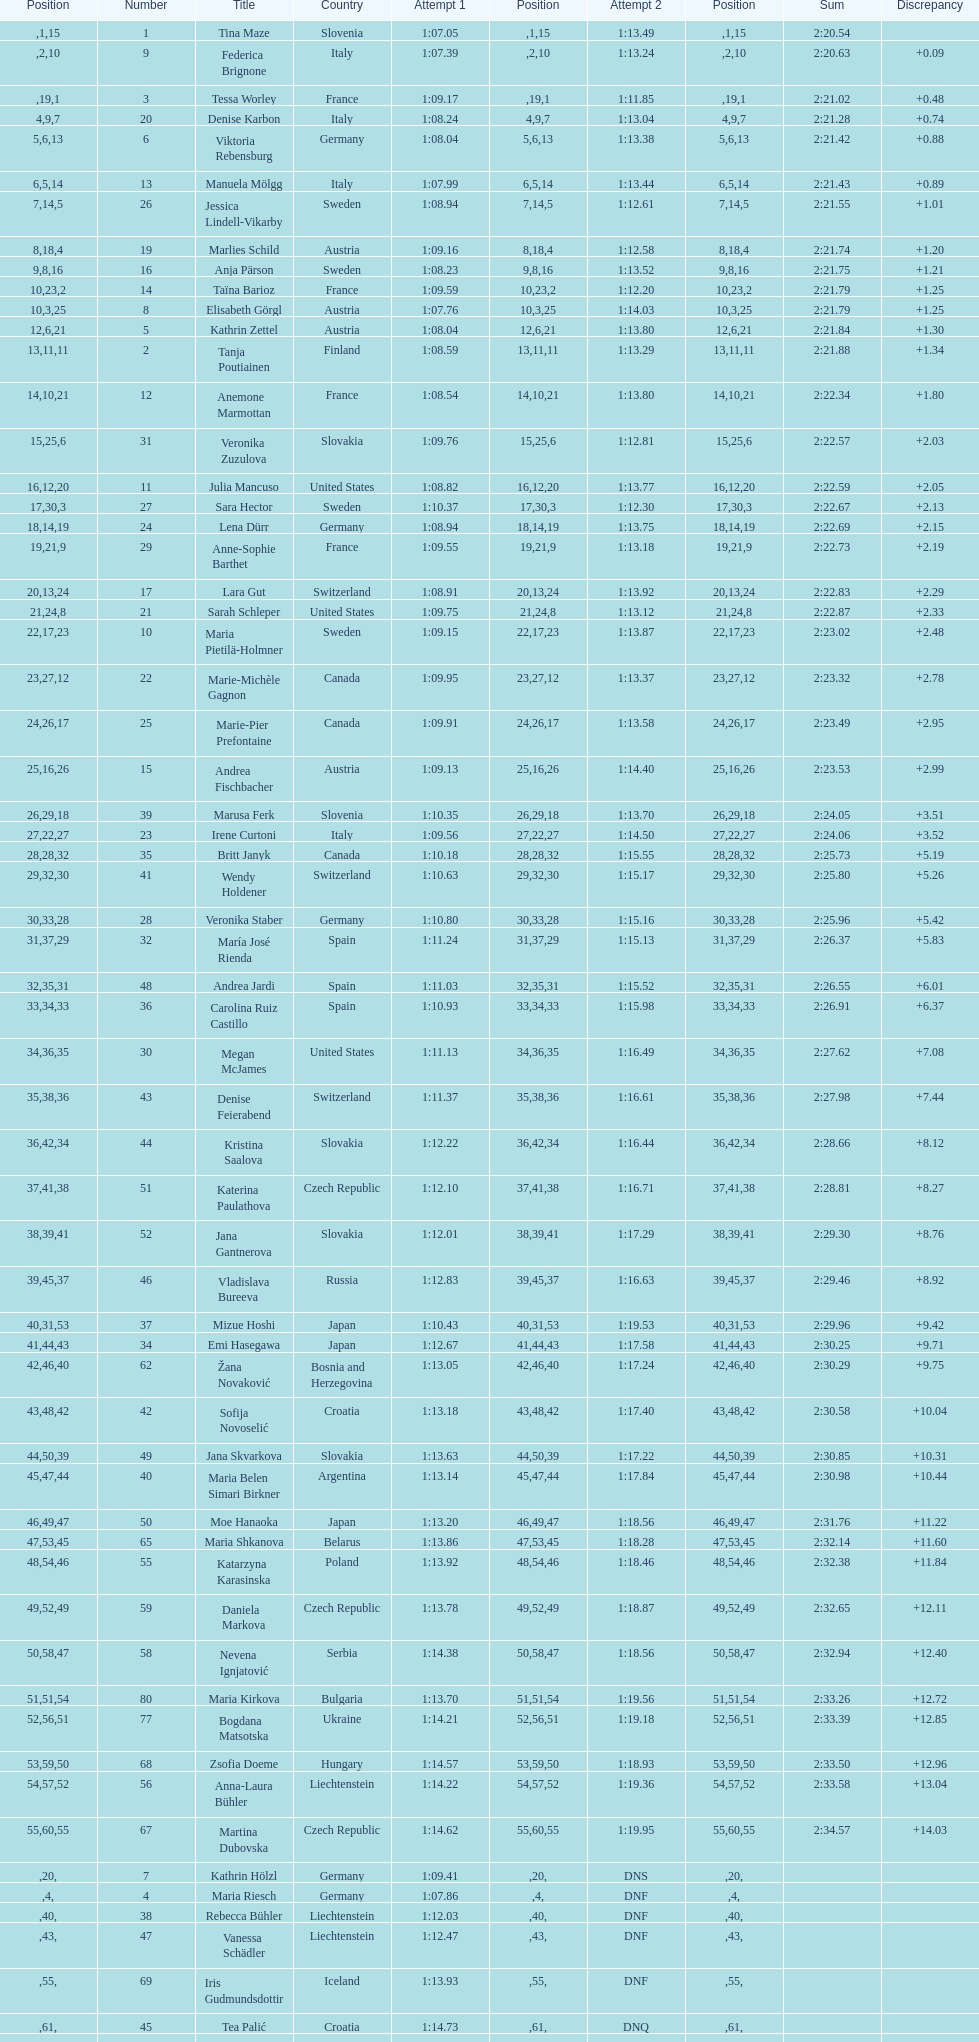Who was the last competitor to actually finish both runs? Martina Dubovska. 